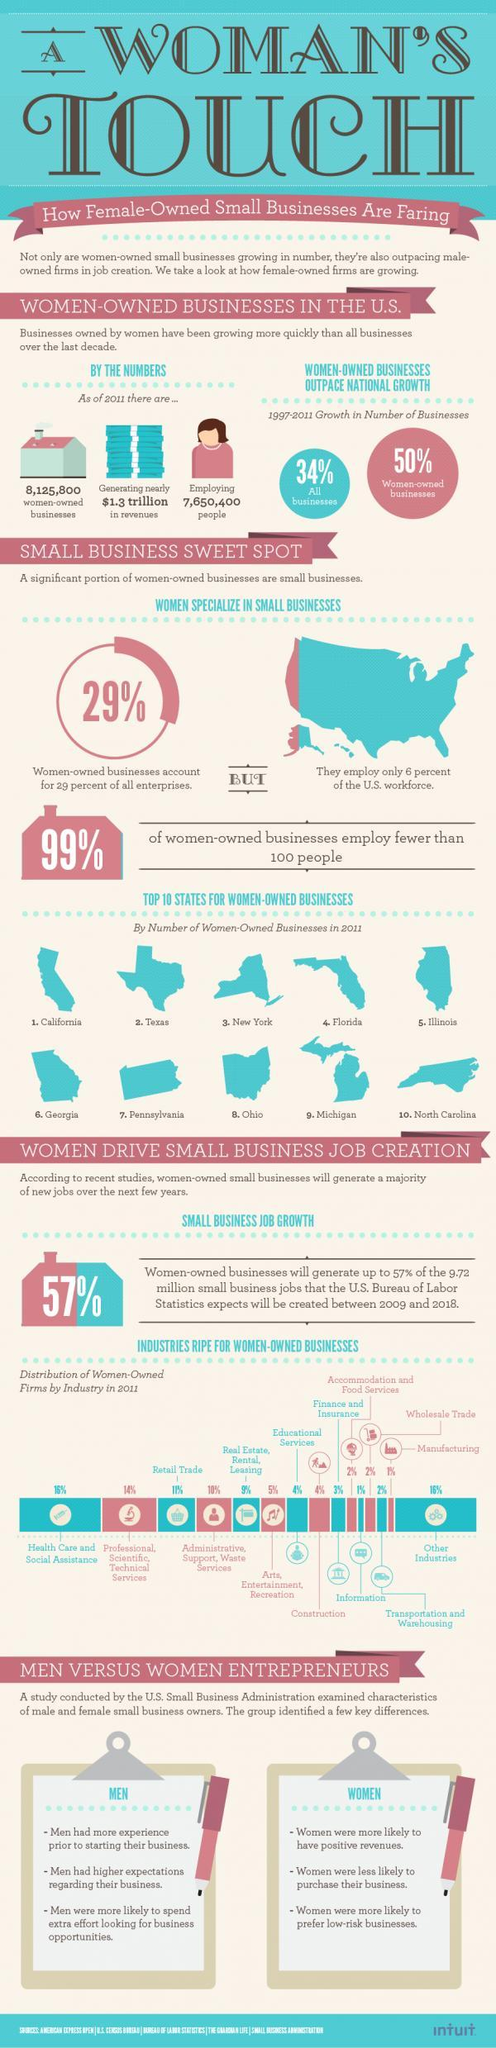What percentage of women owned business hire more than 100 employees?
Answer the question with a short phrase. 1% What is the industries have the distribution rate of 4%? Educational Services, Construction What is the distribution rate of women owned industries in health care and other sectors? 16% 